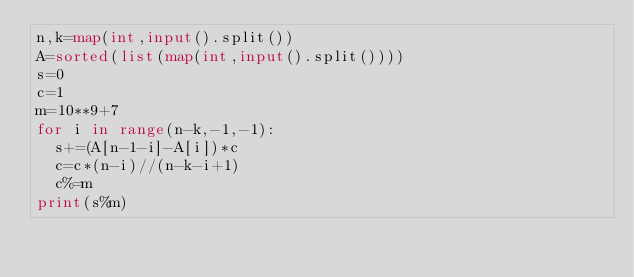Convert code to text. <code><loc_0><loc_0><loc_500><loc_500><_Python_>n,k=map(int,input().split())
A=sorted(list(map(int,input().split())))
s=0
c=1
m=10**9+7
for i in range(n-k,-1,-1):
  s+=(A[n-1-i]-A[i])*c
  c=c*(n-i)//(n-k-i+1)
  c%=m
print(s%m)
</code> 